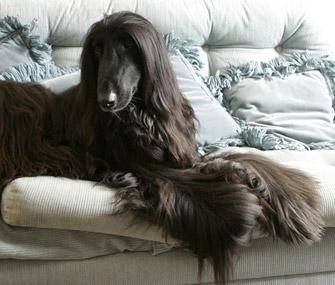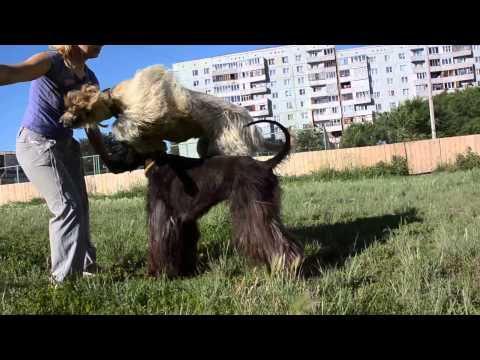The first image is the image on the left, the second image is the image on the right. Assess this claim about the two images: "A woman is on the left of an image, next to a dark afghan hound that stands in profile facing leftward.". Correct or not? Answer yes or no. Yes. The first image is the image on the left, the second image is the image on the right. Considering the images on both sides, is "The dog in the image in the right is standing on in the grass with a person." valid? Answer yes or no. Yes. 